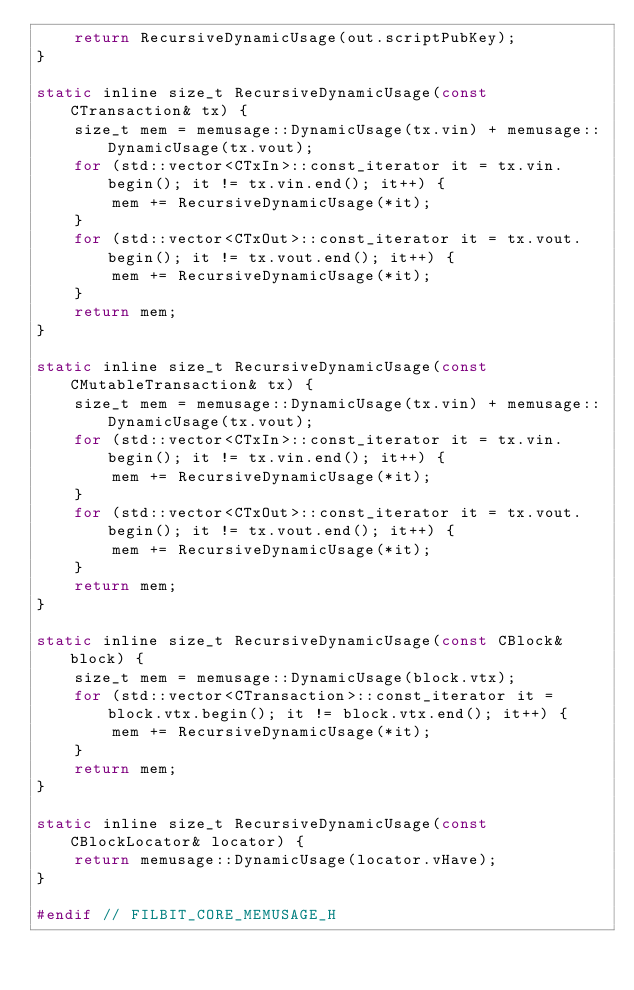Convert code to text. <code><loc_0><loc_0><loc_500><loc_500><_C_>    return RecursiveDynamicUsage(out.scriptPubKey);
}

static inline size_t RecursiveDynamicUsage(const CTransaction& tx) {
    size_t mem = memusage::DynamicUsage(tx.vin) + memusage::DynamicUsage(tx.vout);
    for (std::vector<CTxIn>::const_iterator it = tx.vin.begin(); it != tx.vin.end(); it++) {
        mem += RecursiveDynamicUsage(*it);
    }
    for (std::vector<CTxOut>::const_iterator it = tx.vout.begin(); it != tx.vout.end(); it++) {
        mem += RecursiveDynamicUsage(*it);
    }
    return mem;
}

static inline size_t RecursiveDynamicUsage(const CMutableTransaction& tx) {
    size_t mem = memusage::DynamicUsage(tx.vin) + memusage::DynamicUsage(tx.vout);
    for (std::vector<CTxIn>::const_iterator it = tx.vin.begin(); it != tx.vin.end(); it++) {
        mem += RecursiveDynamicUsage(*it);
    }
    for (std::vector<CTxOut>::const_iterator it = tx.vout.begin(); it != tx.vout.end(); it++) {
        mem += RecursiveDynamicUsage(*it);
    }
    return mem;
}

static inline size_t RecursiveDynamicUsage(const CBlock& block) {
    size_t mem = memusage::DynamicUsage(block.vtx);
    for (std::vector<CTransaction>::const_iterator it = block.vtx.begin(); it != block.vtx.end(); it++) {
        mem += RecursiveDynamicUsage(*it);
    }
    return mem;
}

static inline size_t RecursiveDynamicUsage(const CBlockLocator& locator) {
    return memusage::DynamicUsage(locator.vHave);
}

#endif // FILBIT_CORE_MEMUSAGE_H
</code> 